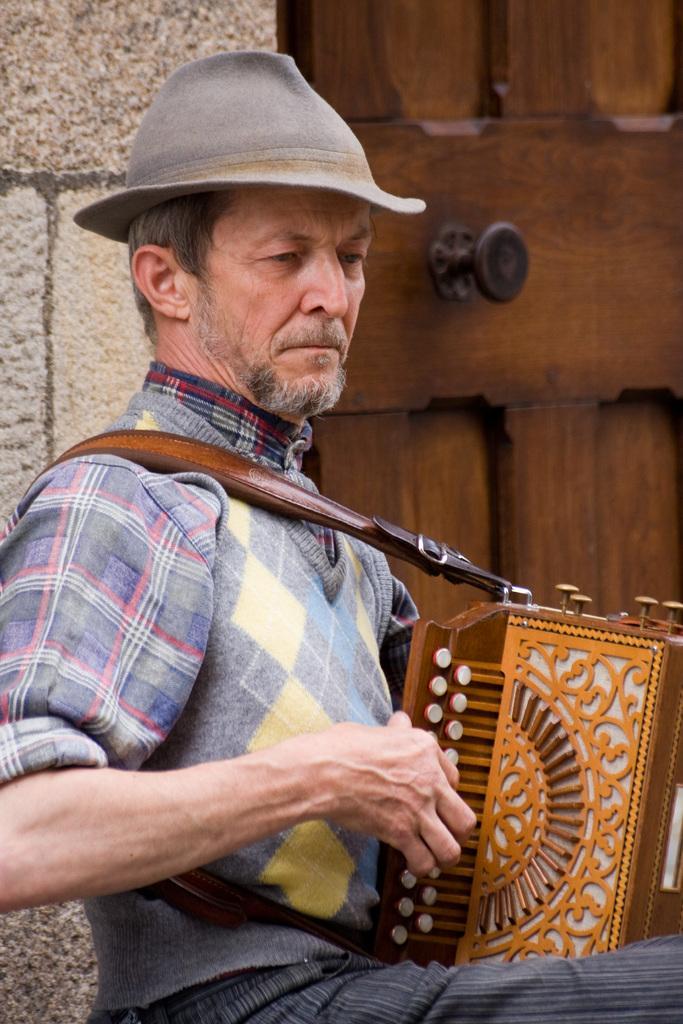Could you give a brief overview of what you see in this image? In this image I can see one man is sitting and I can see he is holding a musical instrument. I can also see he is wearing a hat and in the background I can see a brown colour door. 